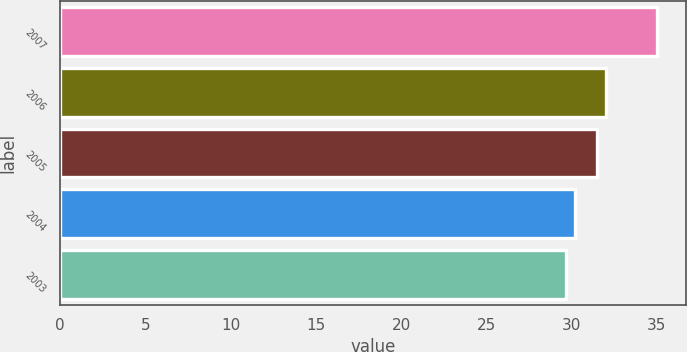<chart> <loc_0><loc_0><loc_500><loc_500><bar_chart><fcel>2007<fcel>2006<fcel>2005<fcel>2004<fcel>2003<nl><fcel>34.98<fcel>32.02<fcel>31.49<fcel>30.17<fcel>29.64<nl></chart> 